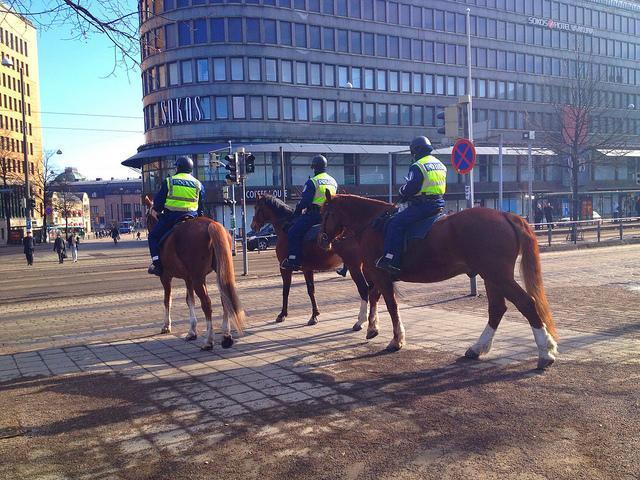How many people are on horseback?
Give a very brief answer. 3. How many horses are there?
Give a very brief answer. 3. How many people are there?
Give a very brief answer. 2. 